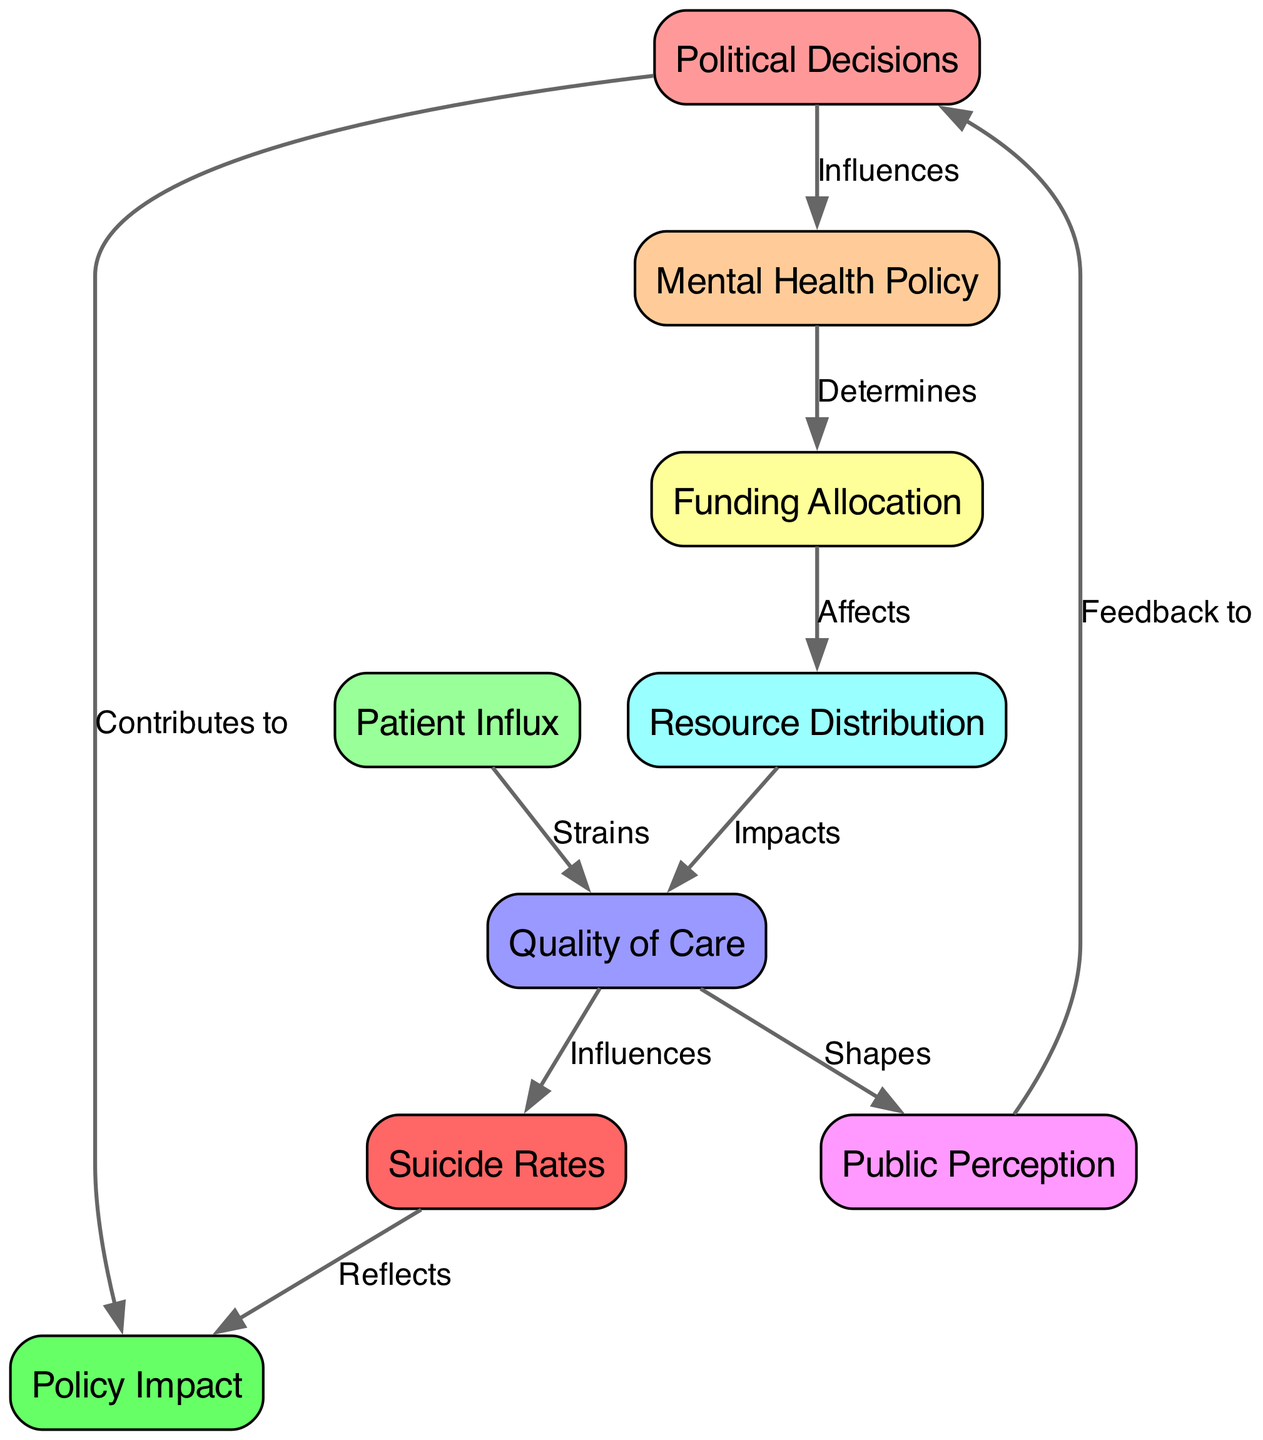What is the total number of nodes in the diagram? The diagram contains 9 nodes: Political Decisions, Mental Health Policy, Funding Allocation, Patient Influx, Resource Distribution, Quality of Care, Public Perception, Suicide Rates, and Policy Impact. Counting them gives us a total of 9.
Answer: 9 What is the relationship between Funding Allocation and Resource Distribution? Funding Allocation directly affects Resource Distribution, as indicated by the edge labeled "Affects" that connects these two nodes in the diagram.
Answer: Affects Which node influences the Quality of Care? Quality of Care is influenced by both Resource Distribution, which impacts its quality, and Patient Influx, which strains it. This is indicated by the edges coming into the Quality of Care node.
Answer: Resource Distribution and Patient Influx What does Public Perception reflect back to? Public Perception reflects feedback back to Political Decisions, as shown by the edge labeled "Feedback to" connecting these nodes in the diagram.
Answer: Political Decisions How do Political Decisions contribute to Policy Impact? Political Decisions contribute to Policy Impact, as indicated by the edge labeled "Contributes to" that connects the Political Decisions node to the Policy Impact node.
Answer: Contributes to How does Quality of Care influence Suicide Rates? Quality of Care influences Suicide Rates, as shown by the edge labeled "Influences" connecting these two nodes, indicating that the quality of care provided can affect the rate of suicides.
Answer: Influences What is the impact of Mental Health Policy on Funding Allocation? Mental Health Policy determines Funding Allocation, as shown by the edge connecting these two nodes labeled "Determines," indicating a direct influence.
Answer: Determines Which node potentially shapes Public Perception? Public Perception is shaped by Quality of Care, as indicated by the edge labeled "Shapes" that connects the Quality of Care node to the Public Perception node.
Answer: Quality of Care What do Suicide Rates reflect concerning political actions? Suicide Rates reflect Policy Impact, as indicated by the edge labeled "Reflects" connecting these two nodes, suggesting that the rates of suicide in society can be a direct reflection of the impacts of political decisions and policies.
Answer: Reflects 